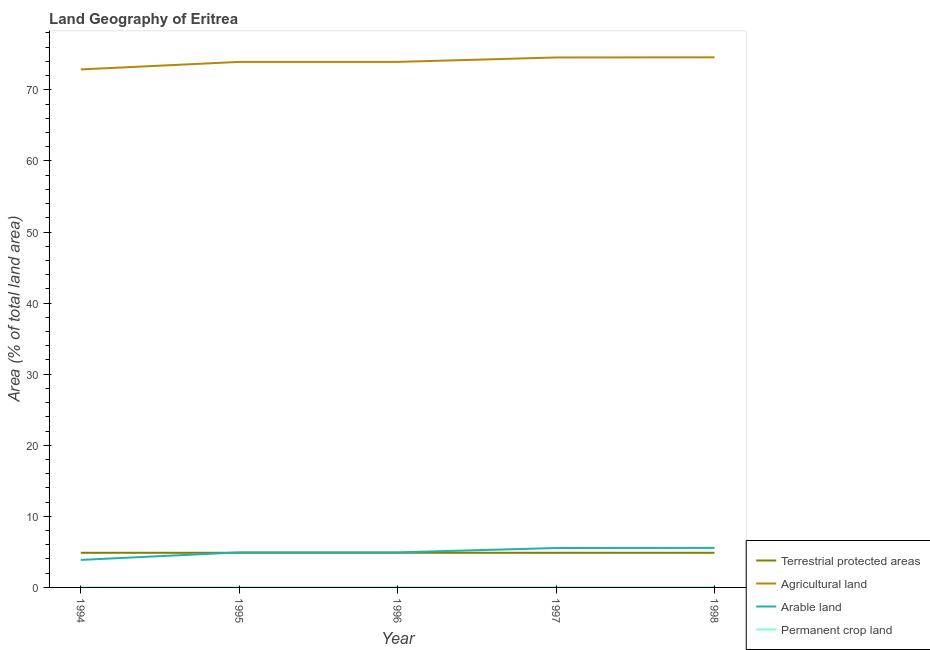Does the line corresponding to percentage of area under arable land intersect with the line corresponding to percentage of land under terrestrial protection?
Provide a short and direct response. Yes. What is the percentage of area under arable land in 1996?
Your answer should be compact. 4.93. Across all years, what is the maximum percentage of area under arable land?
Offer a very short reply. 5.56. Across all years, what is the minimum percentage of area under agricultural land?
Ensure brevity in your answer.  72.87. What is the total percentage of land under terrestrial protection in the graph?
Keep it short and to the point. 24.37. What is the difference between the percentage of area under arable land in 1998 and the percentage of land under terrestrial protection in 1994?
Offer a terse response. 0.69. What is the average percentage of area under permanent crop land per year?
Your answer should be very brief. 0.02. In the year 1996, what is the difference between the percentage of land under terrestrial protection and percentage of area under agricultural land?
Ensure brevity in your answer.  -69.06. What is the ratio of the percentage of area under agricultural land in 1994 to that in 1997?
Ensure brevity in your answer.  0.98. Is the percentage of land under terrestrial protection in 1996 less than that in 1998?
Give a very brief answer. No. What is the difference between the highest and the second highest percentage of land under terrestrial protection?
Offer a very short reply. 0. What is the difference between the highest and the lowest percentage of area under arable land?
Give a very brief answer. 1.69. Is it the case that in every year, the sum of the percentage of land under terrestrial protection and percentage of area under permanent crop land is greater than the sum of percentage of area under arable land and percentage of area under agricultural land?
Give a very brief answer. No. Is the percentage of area under permanent crop land strictly greater than the percentage of land under terrestrial protection over the years?
Ensure brevity in your answer.  No. Is the percentage of area under agricultural land strictly less than the percentage of area under permanent crop land over the years?
Ensure brevity in your answer.  No. How many years are there in the graph?
Keep it short and to the point. 5. Does the graph contain grids?
Offer a very short reply. No. How many legend labels are there?
Your answer should be very brief. 4. What is the title of the graph?
Keep it short and to the point. Land Geography of Eritrea. What is the label or title of the X-axis?
Your response must be concise. Year. What is the label or title of the Y-axis?
Offer a terse response. Area (% of total land area). What is the Area (% of total land area) of Terrestrial protected areas in 1994?
Offer a terse response. 4.87. What is the Area (% of total land area) in Agricultural land in 1994?
Your answer should be very brief. 72.87. What is the Area (% of total land area) in Arable land in 1994?
Offer a very short reply. 3.87. What is the Area (% of total land area) of Permanent crop land in 1994?
Ensure brevity in your answer.  0.02. What is the Area (% of total land area) of Terrestrial protected areas in 1995?
Offer a terse response. 4.87. What is the Area (% of total land area) in Agricultural land in 1995?
Give a very brief answer. 73.93. What is the Area (% of total land area) in Arable land in 1995?
Make the answer very short. 4.93. What is the Area (% of total land area) of Permanent crop land in 1995?
Your answer should be very brief. 0.02. What is the Area (% of total land area) in Terrestrial protected areas in 1996?
Offer a very short reply. 4.87. What is the Area (% of total land area) of Agricultural land in 1996?
Your response must be concise. 73.93. What is the Area (% of total land area) of Arable land in 1996?
Keep it short and to the point. 4.93. What is the Area (% of total land area) in Permanent crop land in 1996?
Give a very brief answer. 0.02. What is the Area (% of total land area) of Terrestrial protected areas in 1997?
Make the answer very short. 4.87. What is the Area (% of total land area) in Agricultural land in 1997?
Offer a very short reply. 74.55. What is the Area (% of total land area) in Arable land in 1997?
Provide a succinct answer. 5.54. What is the Area (% of total land area) of Permanent crop land in 1997?
Provide a succinct answer. 0.03. What is the Area (% of total land area) in Terrestrial protected areas in 1998?
Offer a very short reply. 4.87. What is the Area (% of total land area) of Agricultural land in 1998?
Your answer should be compact. 74.57. What is the Area (% of total land area) of Arable land in 1998?
Offer a terse response. 5.56. What is the Area (% of total land area) in Permanent crop land in 1998?
Ensure brevity in your answer.  0.03. Across all years, what is the maximum Area (% of total land area) in Terrestrial protected areas?
Provide a short and direct response. 4.87. Across all years, what is the maximum Area (% of total land area) of Agricultural land?
Give a very brief answer. 74.57. Across all years, what is the maximum Area (% of total land area) in Arable land?
Make the answer very short. 5.56. Across all years, what is the maximum Area (% of total land area) in Permanent crop land?
Give a very brief answer. 0.03. Across all years, what is the minimum Area (% of total land area) in Terrestrial protected areas?
Your answer should be compact. 4.87. Across all years, what is the minimum Area (% of total land area) in Agricultural land?
Your answer should be very brief. 72.87. Across all years, what is the minimum Area (% of total land area) in Arable land?
Your response must be concise. 3.87. Across all years, what is the minimum Area (% of total land area) of Permanent crop land?
Provide a short and direct response. 0.02. What is the total Area (% of total land area) of Terrestrial protected areas in the graph?
Your answer should be compact. 24.37. What is the total Area (% of total land area) in Agricultural land in the graph?
Give a very brief answer. 369.86. What is the total Area (% of total land area) in Arable land in the graph?
Provide a succinct answer. 24.84. What is the total Area (% of total land area) of Permanent crop land in the graph?
Make the answer very short. 0.12. What is the difference between the Area (% of total land area) of Agricultural land in 1994 and that in 1995?
Give a very brief answer. -1.06. What is the difference between the Area (% of total land area) in Arable land in 1994 and that in 1995?
Your answer should be very brief. -1.06. What is the difference between the Area (% of total land area) of Agricultural land in 1994 and that in 1996?
Your response must be concise. -1.06. What is the difference between the Area (% of total land area) in Arable land in 1994 and that in 1996?
Your answer should be very brief. -1.06. What is the difference between the Area (% of total land area) of Permanent crop land in 1994 and that in 1996?
Keep it short and to the point. 0. What is the difference between the Area (% of total land area) in Terrestrial protected areas in 1994 and that in 1997?
Make the answer very short. 0. What is the difference between the Area (% of total land area) of Agricultural land in 1994 and that in 1997?
Provide a succinct answer. -1.68. What is the difference between the Area (% of total land area) in Arable land in 1994 and that in 1997?
Your answer should be compact. -1.67. What is the difference between the Area (% of total land area) in Permanent crop land in 1994 and that in 1997?
Make the answer very short. -0.01. What is the difference between the Area (% of total land area) of Agricultural land in 1994 and that in 1998?
Provide a short and direct response. -1.7. What is the difference between the Area (% of total land area) in Arable land in 1994 and that in 1998?
Give a very brief answer. -1.69. What is the difference between the Area (% of total land area) of Permanent crop land in 1994 and that in 1998?
Make the answer very short. -0.01. What is the difference between the Area (% of total land area) in Terrestrial protected areas in 1995 and that in 1996?
Offer a terse response. 0. What is the difference between the Area (% of total land area) of Arable land in 1995 and that in 1996?
Your response must be concise. 0. What is the difference between the Area (% of total land area) of Agricultural land in 1995 and that in 1997?
Keep it short and to the point. -0.62. What is the difference between the Area (% of total land area) in Arable land in 1995 and that in 1997?
Offer a terse response. -0.61. What is the difference between the Area (% of total land area) in Permanent crop land in 1995 and that in 1997?
Offer a very short reply. -0.01. What is the difference between the Area (% of total land area) of Agricultural land in 1995 and that in 1998?
Offer a terse response. -0.64. What is the difference between the Area (% of total land area) in Arable land in 1995 and that in 1998?
Ensure brevity in your answer.  -0.63. What is the difference between the Area (% of total land area) in Permanent crop land in 1995 and that in 1998?
Your response must be concise. -0.01. What is the difference between the Area (% of total land area) in Agricultural land in 1996 and that in 1997?
Provide a succinct answer. -0.62. What is the difference between the Area (% of total land area) of Arable land in 1996 and that in 1997?
Provide a short and direct response. -0.61. What is the difference between the Area (% of total land area) in Permanent crop land in 1996 and that in 1997?
Make the answer very short. -0.01. What is the difference between the Area (% of total land area) of Agricultural land in 1996 and that in 1998?
Keep it short and to the point. -0.64. What is the difference between the Area (% of total land area) in Arable land in 1996 and that in 1998?
Your response must be concise. -0.63. What is the difference between the Area (% of total land area) in Permanent crop land in 1996 and that in 1998?
Give a very brief answer. -0.01. What is the difference between the Area (% of total land area) in Agricultural land in 1997 and that in 1998?
Provide a short and direct response. -0.02. What is the difference between the Area (% of total land area) of Arable land in 1997 and that in 1998?
Provide a succinct answer. -0.02. What is the difference between the Area (% of total land area) of Terrestrial protected areas in 1994 and the Area (% of total land area) of Agricultural land in 1995?
Give a very brief answer. -69.06. What is the difference between the Area (% of total land area) in Terrestrial protected areas in 1994 and the Area (% of total land area) in Arable land in 1995?
Your response must be concise. -0.06. What is the difference between the Area (% of total land area) in Terrestrial protected areas in 1994 and the Area (% of total land area) in Permanent crop land in 1995?
Your answer should be compact. 4.85. What is the difference between the Area (% of total land area) in Agricultural land in 1994 and the Area (% of total land area) in Arable land in 1995?
Offer a terse response. 67.94. What is the difference between the Area (% of total land area) in Agricultural land in 1994 and the Area (% of total land area) in Permanent crop land in 1995?
Provide a succinct answer. 72.85. What is the difference between the Area (% of total land area) of Arable land in 1994 and the Area (% of total land area) of Permanent crop land in 1995?
Ensure brevity in your answer.  3.85. What is the difference between the Area (% of total land area) of Terrestrial protected areas in 1994 and the Area (% of total land area) of Agricultural land in 1996?
Ensure brevity in your answer.  -69.06. What is the difference between the Area (% of total land area) in Terrestrial protected areas in 1994 and the Area (% of total land area) in Arable land in 1996?
Keep it short and to the point. -0.06. What is the difference between the Area (% of total land area) in Terrestrial protected areas in 1994 and the Area (% of total land area) in Permanent crop land in 1996?
Provide a short and direct response. 4.85. What is the difference between the Area (% of total land area) in Agricultural land in 1994 and the Area (% of total land area) in Arable land in 1996?
Offer a very short reply. 67.94. What is the difference between the Area (% of total land area) of Agricultural land in 1994 and the Area (% of total land area) of Permanent crop land in 1996?
Make the answer very short. 72.85. What is the difference between the Area (% of total land area) in Arable land in 1994 and the Area (% of total land area) in Permanent crop land in 1996?
Your response must be concise. 3.85. What is the difference between the Area (% of total land area) of Terrestrial protected areas in 1994 and the Area (% of total land area) of Agricultural land in 1997?
Keep it short and to the point. -69.68. What is the difference between the Area (% of total land area) in Terrestrial protected areas in 1994 and the Area (% of total land area) in Arable land in 1997?
Offer a terse response. -0.67. What is the difference between the Area (% of total land area) of Terrestrial protected areas in 1994 and the Area (% of total land area) of Permanent crop land in 1997?
Give a very brief answer. 4.84. What is the difference between the Area (% of total land area) in Agricultural land in 1994 and the Area (% of total land area) in Arable land in 1997?
Give a very brief answer. 67.33. What is the difference between the Area (% of total land area) in Agricultural land in 1994 and the Area (% of total land area) in Permanent crop land in 1997?
Your answer should be compact. 72.84. What is the difference between the Area (% of total land area) in Arable land in 1994 and the Area (% of total land area) in Permanent crop land in 1997?
Offer a very short reply. 3.84. What is the difference between the Area (% of total land area) of Terrestrial protected areas in 1994 and the Area (% of total land area) of Agricultural land in 1998?
Keep it short and to the point. -69.7. What is the difference between the Area (% of total land area) in Terrestrial protected areas in 1994 and the Area (% of total land area) in Arable land in 1998?
Your answer should be very brief. -0.69. What is the difference between the Area (% of total land area) of Terrestrial protected areas in 1994 and the Area (% of total land area) of Permanent crop land in 1998?
Give a very brief answer. 4.84. What is the difference between the Area (% of total land area) in Agricultural land in 1994 and the Area (% of total land area) in Arable land in 1998?
Your response must be concise. 67.31. What is the difference between the Area (% of total land area) in Agricultural land in 1994 and the Area (% of total land area) in Permanent crop land in 1998?
Provide a short and direct response. 72.84. What is the difference between the Area (% of total land area) of Arable land in 1994 and the Area (% of total land area) of Permanent crop land in 1998?
Ensure brevity in your answer.  3.84. What is the difference between the Area (% of total land area) of Terrestrial protected areas in 1995 and the Area (% of total land area) of Agricultural land in 1996?
Make the answer very short. -69.06. What is the difference between the Area (% of total land area) in Terrestrial protected areas in 1995 and the Area (% of total land area) in Arable land in 1996?
Give a very brief answer. -0.06. What is the difference between the Area (% of total land area) in Terrestrial protected areas in 1995 and the Area (% of total land area) in Permanent crop land in 1996?
Offer a very short reply. 4.85. What is the difference between the Area (% of total land area) of Agricultural land in 1995 and the Area (% of total land area) of Arable land in 1996?
Your answer should be very brief. 69. What is the difference between the Area (% of total land area) in Agricultural land in 1995 and the Area (% of total land area) in Permanent crop land in 1996?
Your answer should be very brief. 73.91. What is the difference between the Area (% of total land area) of Arable land in 1995 and the Area (% of total land area) of Permanent crop land in 1996?
Make the answer very short. 4.91. What is the difference between the Area (% of total land area) of Terrestrial protected areas in 1995 and the Area (% of total land area) of Agricultural land in 1997?
Provide a succinct answer. -69.68. What is the difference between the Area (% of total land area) in Terrestrial protected areas in 1995 and the Area (% of total land area) in Arable land in 1997?
Offer a very short reply. -0.67. What is the difference between the Area (% of total land area) in Terrestrial protected areas in 1995 and the Area (% of total land area) in Permanent crop land in 1997?
Provide a short and direct response. 4.84. What is the difference between the Area (% of total land area) in Agricultural land in 1995 and the Area (% of total land area) in Arable land in 1997?
Your answer should be compact. 68.39. What is the difference between the Area (% of total land area) in Agricultural land in 1995 and the Area (% of total land area) in Permanent crop land in 1997?
Offer a very short reply. 73.9. What is the difference between the Area (% of total land area) in Arable land in 1995 and the Area (% of total land area) in Permanent crop land in 1997?
Offer a very short reply. 4.9. What is the difference between the Area (% of total land area) of Terrestrial protected areas in 1995 and the Area (% of total land area) of Agricultural land in 1998?
Your response must be concise. -69.7. What is the difference between the Area (% of total land area) of Terrestrial protected areas in 1995 and the Area (% of total land area) of Arable land in 1998?
Your answer should be compact. -0.69. What is the difference between the Area (% of total land area) of Terrestrial protected areas in 1995 and the Area (% of total land area) of Permanent crop land in 1998?
Provide a succinct answer. 4.84. What is the difference between the Area (% of total land area) of Agricultural land in 1995 and the Area (% of total land area) of Arable land in 1998?
Make the answer very short. 68.37. What is the difference between the Area (% of total land area) in Agricultural land in 1995 and the Area (% of total land area) in Permanent crop land in 1998?
Give a very brief answer. 73.9. What is the difference between the Area (% of total land area) of Arable land in 1995 and the Area (% of total land area) of Permanent crop land in 1998?
Provide a succinct answer. 4.9. What is the difference between the Area (% of total land area) in Terrestrial protected areas in 1996 and the Area (% of total land area) in Agricultural land in 1997?
Provide a succinct answer. -69.68. What is the difference between the Area (% of total land area) of Terrestrial protected areas in 1996 and the Area (% of total land area) of Arable land in 1997?
Provide a succinct answer. -0.67. What is the difference between the Area (% of total land area) of Terrestrial protected areas in 1996 and the Area (% of total land area) of Permanent crop land in 1997?
Keep it short and to the point. 4.84. What is the difference between the Area (% of total land area) in Agricultural land in 1996 and the Area (% of total land area) in Arable land in 1997?
Your answer should be compact. 68.39. What is the difference between the Area (% of total land area) of Agricultural land in 1996 and the Area (% of total land area) of Permanent crop land in 1997?
Your answer should be very brief. 73.9. What is the difference between the Area (% of total land area) in Arable land in 1996 and the Area (% of total land area) in Permanent crop land in 1997?
Your response must be concise. 4.9. What is the difference between the Area (% of total land area) in Terrestrial protected areas in 1996 and the Area (% of total land area) in Agricultural land in 1998?
Ensure brevity in your answer.  -69.7. What is the difference between the Area (% of total land area) in Terrestrial protected areas in 1996 and the Area (% of total land area) in Arable land in 1998?
Offer a terse response. -0.69. What is the difference between the Area (% of total land area) of Terrestrial protected areas in 1996 and the Area (% of total land area) of Permanent crop land in 1998?
Keep it short and to the point. 4.84. What is the difference between the Area (% of total land area) in Agricultural land in 1996 and the Area (% of total land area) in Arable land in 1998?
Your answer should be compact. 68.37. What is the difference between the Area (% of total land area) in Agricultural land in 1996 and the Area (% of total land area) in Permanent crop land in 1998?
Ensure brevity in your answer.  73.9. What is the difference between the Area (% of total land area) of Arable land in 1996 and the Area (% of total land area) of Permanent crop land in 1998?
Your answer should be compact. 4.9. What is the difference between the Area (% of total land area) in Terrestrial protected areas in 1997 and the Area (% of total land area) in Agricultural land in 1998?
Give a very brief answer. -69.7. What is the difference between the Area (% of total land area) in Terrestrial protected areas in 1997 and the Area (% of total land area) in Arable land in 1998?
Give a very brief answer. -0.69. What is the difference between the Area (% of total land area) in Terrestrial protected areas in 1997 and the Area (% of total land area) in Permanent crop land in 1998?
Your answer should be compact. 4.84. What is the difference between the Area (% of total land area) of Agricultural land in 1997 and the Area (% of total land area) of Arable land in 1998?
Ensure brevity in your answer.  68.99. What is the difference between the Area (% of total land area) of Agricultural land in 1997 and the Area (% of total land area) of Permanent crop land in 1998?
Your answer should be very brief. 74.52. What is the difference between the Area (% of total land area) in Arable land in 1997 and the Area (% of total land area) in Permanent crop land in 1998?
Your answer should be compact. 5.51. What is the average Area (% of total land area) in Terrestrial protected areas per year?
Provide a short and direct response. 4.87. What is the average Area (% of total land area) of Agricultural land per year?
Give a very brief answer. 73.97. What is the average Area (% of total land area) in Arable land per year?
Provide a succinct answer. 4.97. What is the average Area (% of total land area) in Permanent crop land per year?
Offer a terse response. 0.02. In the year 1994, what is the difference between the Area (% of total land area) of Terrestrial protected areas and Area (% of total land area) of Agricultural land?
Offer a very short reply. -68. In the year 1994, what is the difference between the Area (% of total land area) of Terrestrial protected areas and Area (% of total land area) of Arable land?
Keep it short and to the point. 1. In the year 1994, what is the difference between the Area (% of total land area) in Terrestrial protected areas and Area (% of total land area) in Permanent crop land?
Offer a terse response. 4.85. In the year 1994, what is the difference between the Area (% of total land area) in Agricultural land and Area (% of total land area) in Permanent crop land?
Give a very brief answer. 72.85. In the year 1994, what is the difference between the Area (% of total land area) in Arable land and Area (% of total land area) in Permanent crop land?
Your response must be concise. 3.85. In the year 1995, what is the difference between the Area (% of total land area) of Terrestrial protected areas and Area (% of total land area) of Agricultural land?
Your answer should be very brief. -69.06. In the year 1995, what is the difference between the Area (% of total land area) in Terrestrial protected areas and Area (% of total land area) in Arable land?
Ensure brevity in your answer.  -0.06. In the year 1995, what is the difference between the Area (% of total land area) in Terrestrial protected areas and Area (% of total land area) in Permanent crop land?
Provide a short and direct response. 4.85. In the year 1995, what is the difference between the Area (% of total land area) in Agricultural land and Area (% of total land area) in Permanent crop land?
Give a very brief answer. 73.91. In the year 1995, what is the difference between the Area (% of total land area) in Arable land and Area (% of total land area) in Permanent crop land?
Your answer should be compact. 4.91. In the year 1996, what is the difference between the Area (% of total land area) in Terrestrial protected areas and Area (% of total land area) in Agricultural land?
Your answer should be compact. -69.06. In the year 1996, what is the difference between the Area (% of total land area) of Terrestrial protected areas and Area (% of total land area) of Arable land?
Offer a terse response. -0.06. In the year 1996, what is the difference between the Area (% of total land area) of Terrestrial protected areas and Area (% of total land area) of Permanent crop land?
Offer a very short reply. 4.85. In the year 1996, what is the difference between the Area (% of total land area) of Agricultural land and Area (% of total land area) of Arable land?
Your answer should be compact. 69. In the year 1996, what is the difference between the Area (% of total land area) in Agricultural land and Area (% of total land area) in Permanent crop land?
Make the answer very short. 73.91. In the year 1996, what is the difference between the Area (% of total land area) in Arable land and Area (% of total land area) in Permanent crop land?
Keep it short and to the point. 4.91. In the year 1997, what is the difference between the Area (% of total land area) in Terrestrial protected areas and Area (% of total land area) in Agricultural land?
Give a very brief answer. -69.68. In the year 1997, what is the difference between the Area (% of total land area) in Terrestrial protected areas and Area (% of total land area) in Arable land?
Your answer should be very brief. -0.67. In the year 1997, what is the difference between the Area (% of total land area) of Terrestrial protected areas and Area (% of total land area) of Permanent crop land?
Offer a terse response. 4.84. In the year 1997, what is the difference between the Area (% of total land area) in Agricultural land and Area (% of total land area) in Arable land?
Offer a terse response. 69.01. In the year 1997, what is the difference between the Area (% of total land area) of Agricultural land and Area (% of total land area) of Permanent crop land?
Offer a terse response. 74.52. In the year 1997, what is the difference between the Area (% of total land area) of Arable land and Area (% of total land area) of Permanent crop land?
Your answer should be compact. 5.51. In the year 1998, what is the difference between the Area (% of total land area) in Terrestrial protected areas and Area (% of total land area) in Agricultural land?
Provide a succinct answer. -69.7. In the year 1998, what is the difference between the Area (% of total land area) in Terrestrial protected areas and Area (% of total land area) in Arable land?
Ensure brevity in your answer.  -0.69. In the year 1998, what is the difference between the Area (% of total land area) of Terrestrial protected areas and Area (% of total land area) of Permanent crop land?
Keep it short and to the point. 4.84. In the year 1998, what is the difference between the Area (% of total land area) of Agricultural land and Area (% of total land area) of Arable land?
Ensure brevity in your answer.  69.01. In the year 1998, what is the difference between the Area (% of total land area) in Agricultural land and Area (% of total land area) in Permanent crop land?
Your answer should be very brief. 74.54. In the year 1998, what is the difference between the Area (% of total land area) in Arable land and Area (% of total land area) in Permanent crop land?
Provide a short and direct response. 5.53. What is the ratio of the Area (% of total land area) of Terrestrial protected areas in 1994 to that in 1995?
Provide a succinct answer. 1. What is the ratio of the Area (% of total land area) of Agricultural land in 1994 to that in 1995?
Your answer should be compact. 0.99. What is the ratio of the Area (% of total land area) in Arable land in 1994 to that in 1995?
Ensure brevity in your answer.  0.79. What is the ratio of the Area (% of total land area) of Agricultural land in 1994 to that in 1996?
Offer a very short reply. 0.99. What is the ratio of the Area (% of total land area) in Arable land in 1994 to that in 1996?
Keep it short and to the point. 0.79. What is the ratio of the Area (% of total land area) in Permanent crop land in 1994 to that in 1996?
Provide a short and direct response. 1. What is the ratio of the Area (% of total land area) of Terrestrial protected areas in 1994 to that in 1997?
Give a very brief answer. 1. What is the ratio of the Area (% of total land area) of Agricultural land in 1994 to that in 1997?
Keep it short and to the point. 0.98. What is the ratio of the Area (% of total land area) in Arable land in 1994 to that in 1997?
Your answer should be very brief. 0.7. What is the ratio of the Area (% of total land area) of Permanent crop land in 1994 to that in 1997?
Offer a very short reply. 0.67. What is the ratio of the Area (% of total land area) in Agricultural land in 1994 to that in 1998?
Make the answer very short. 0.98. What is the ratio of the Area (% of total land area) in Arable land in 1994 to that in 1998?
Offer a very short reply. 0.7. What is the ratio of the Area (% of total land area) of Permanent crop land in 1994 to that in 1998?
Ensure brevity in your answer.  0.67. What is the ratio of the Area (% of total land area) in Terrestrial protected areas in 1995 to that in 1996?
Keep it short and to the point. 1. What is the ratio of the Area (% of total land area) in Agricultural land in 1995 to that in 1996?
Offer a terse response. 1. What is the ratio of the Area (% of total land area) of Arable land in 1995 to that in 1996?
Your answer should be very brief. 1. What is the ratio of the Area (% of total land area) of Permanent crop land in 1995 to that in 1996?
Your answer should be very brief. 1. What is the ratio of the Area (% of total land area) in Terrestrial protected areas in 1995 to that in 1997?
Offer a very short reply. 1. What is the ratio of the Area (% of total land area) of Agricultural land in 1995 to that in 1997?
Provide a short and direct response. 0.99. What is the ratio of the Area (% of total land area) of Arable land in 1995 to that in 1997?
Provide a succinct answer. 0.89. What is the ratio of the Area (% of total land area) in Arable land in 1995 to that in 1998?
Offer a terse response. 0.89. What is the ratio of the Area (% of total land area) of Permanent crop land in 1995 to that in 1998?
Provide a short and direct response. 0.67. What is the ratio of the Area (% of total land area) of Terrestrial protected areas in 1996 to that in 1997?
Provide a succinct answer. 1. What is the ratio of the Area (% of total land area) in Agricultural land in 1996 to that in 1997?
Ensure brevity in your answer.  0.99. What is the ratio of the Area (% of total land area) of Arable land in 1996 to that in 1997?
Offer a terse response. 0.89. What is the ratio of the Area (% of total land area) in Arable land in 1996 to that in 1998?
Give a very brief answer. 0.89. What is the ratio of the Area (% of total land area) of Terrestrial protected areas in 1997 to that in 1998?
Your response must be concise. 1. What is the ratio of the Area (% of total land area) in Arable land in 1997 to that in 1998?
Give a very brief answer. 1. What is the ratio of the Area (% of total land area) in Permanent crop land in 1997 to that in 1998?
Your response must be concise. 1. What is the difference between the highest and the second highest Area (% of total land area) of Agricultural land?
Your response must be concise. 0.02. What is the difference between the highest and the second highest Area (% of total land area) of Arable land?
Offer a terse response. 0.02. What is the difference between the highest and the lowest Area (% of total land area) of Agricultural land?
Give a very brief answer. 1.7. What is the difference between the highest and the lowest Area (% of total land area) of Arable land?
Make the answer very short. 1.69. What is the difference between the highest and the lowest Area (% of total land area) in Permanent crop land?
Offer a terse response. 0.01. 